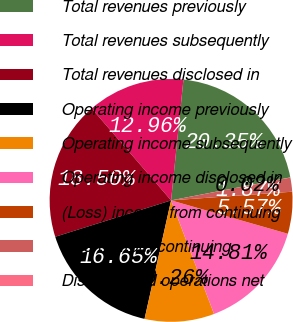<chart> <loc_0><loc_0><loc_500><loc_500><pie_chart><fcel>Total revenues previously<fcel>Total revenues subsequently<fcel>Total revenues disclosed in<fcel>Operating income previously<fcel>Operating income subsequently<fcel>Operating income disclosed in<fcel>(Loss) income from continuing<fcel>Income from continuing<fcel>Discontinued operations net<nl><fcel>20.35%<fcel>12.96%<fcel>18.5%<fcel>16.65%<fcel>9.26%<fcel>14.81%<fcel>5.57%<fcel>1.87%<fcel>0.02%<nl></chart> 